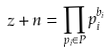<formula> <loc_0><loc_0><loc_500><loc_500>z + n = \prod _ { p _ { i } \in P } p _ { i } ^ { b _ { i } }</formula> 